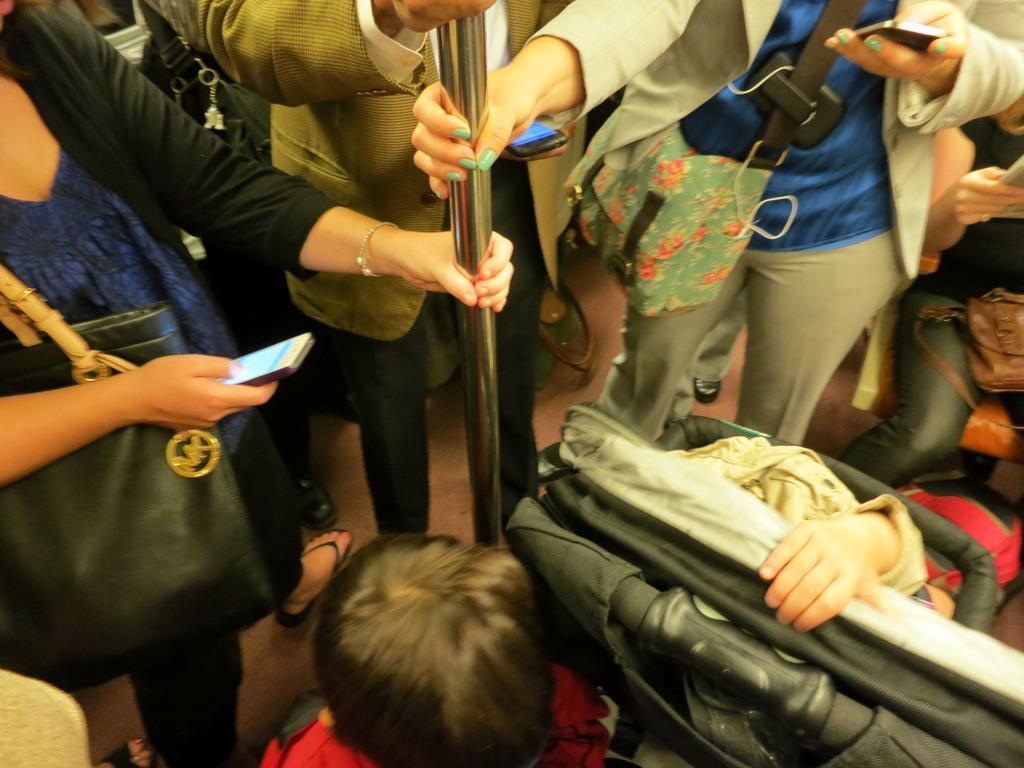How would you summarize this image in a sentence or two? There are three persons standing at the top of this image are holding a rod, and there are some persons sitting as we can see at the bottom of this image. 